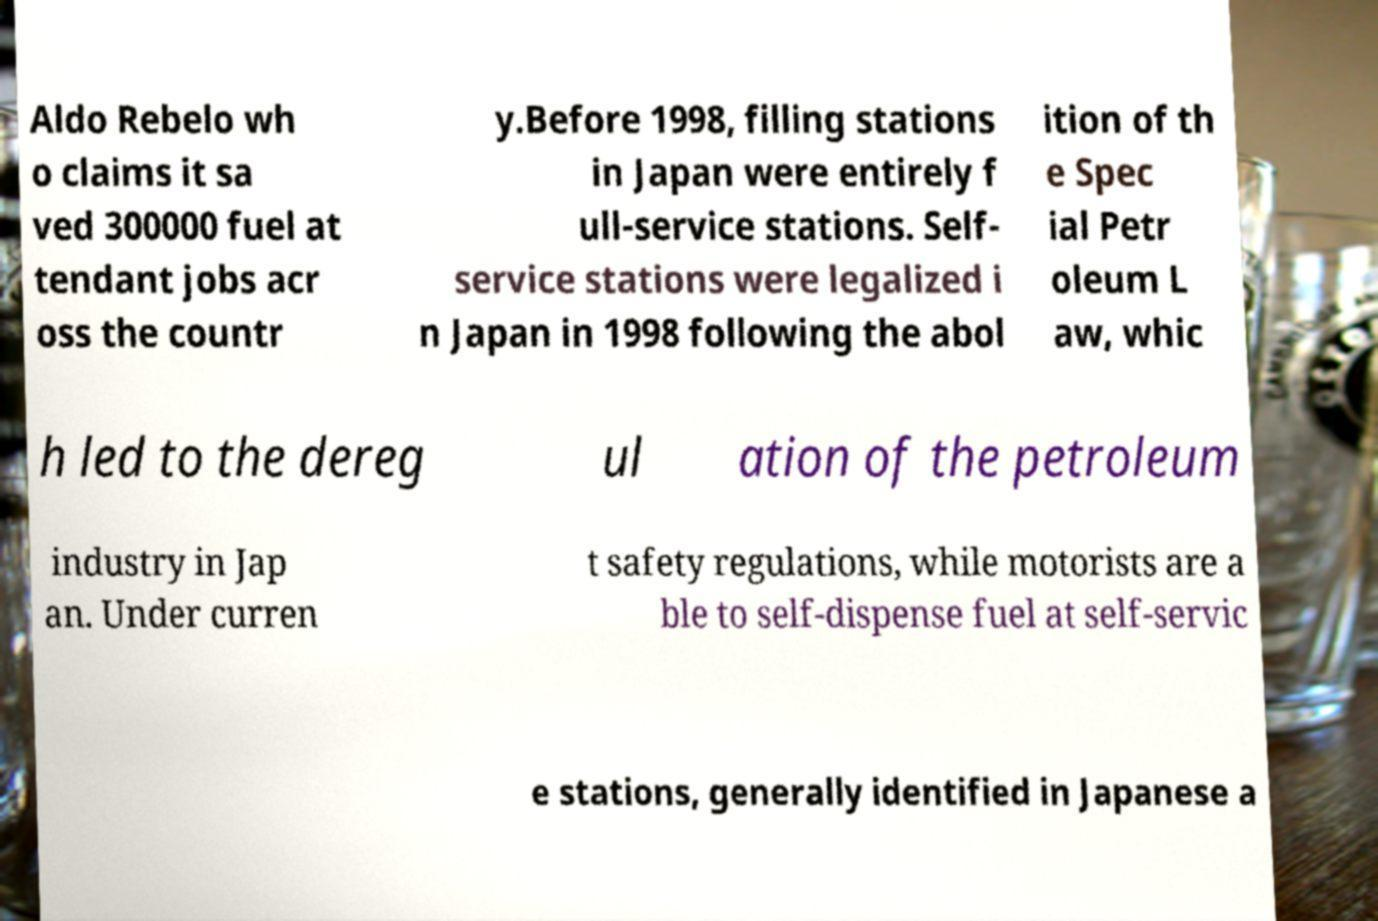For documentation purposes, I need the text within this image transcribed. Could you provide that? Aldo Rebelo wh o claims it sa ved 300000 fuel at tendant jobs acr oss the countr y.Before 1998, filling stations in Japan were entirely f ull-service stations. Self- service stations were legalized i n Japan in 1998 following the abol ition of th e Spec ial Petr oleum L aw, whic h led to the dereg ul ation of the petroleum industry in Jap an. Under curren t safety regulations, while motorists are a ble to self-dispense fuel at self-servic e stations, generally identified in Japanese a 